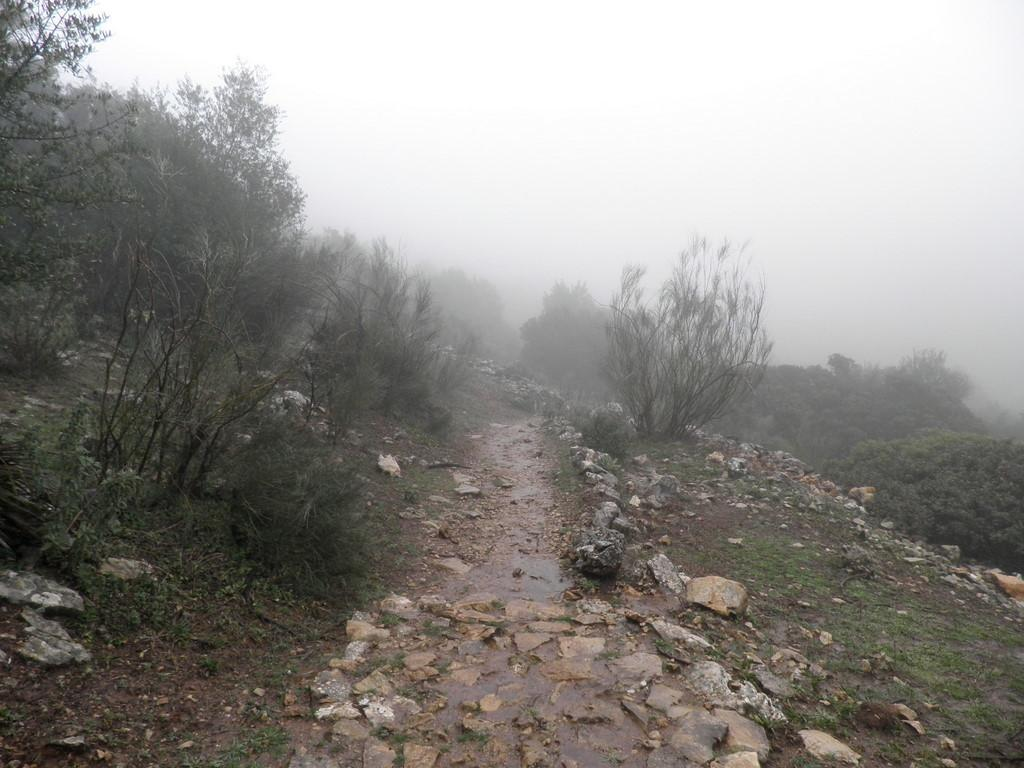What type of natural elements can be seen in the image? There are stones, plants, and trees visible in the image. What atmospheric condition is present in the image? There is fog visible in the image. What type of flesh can be seen on the trees in the image? There is no flesh present on the trees in the image; they are covered in bark. 